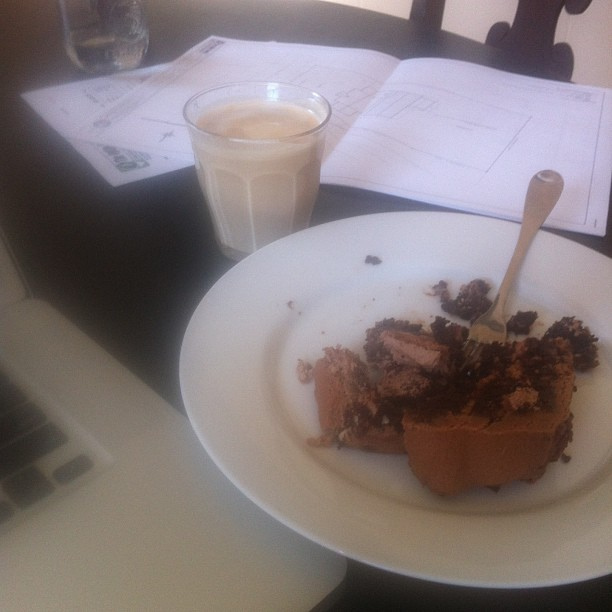<image>What kind of leaf is on the desert? There is no leaf on the desert. However, it can be mint, lettuce, parsley, bay, or maple. What kind of leaf is on the desert? I am not sure what kind of leaf is on the desert. It can be seen 'mint', 'lettuce', 'parsley', 'unknown', 'bay', 'green' or 'maple'. 